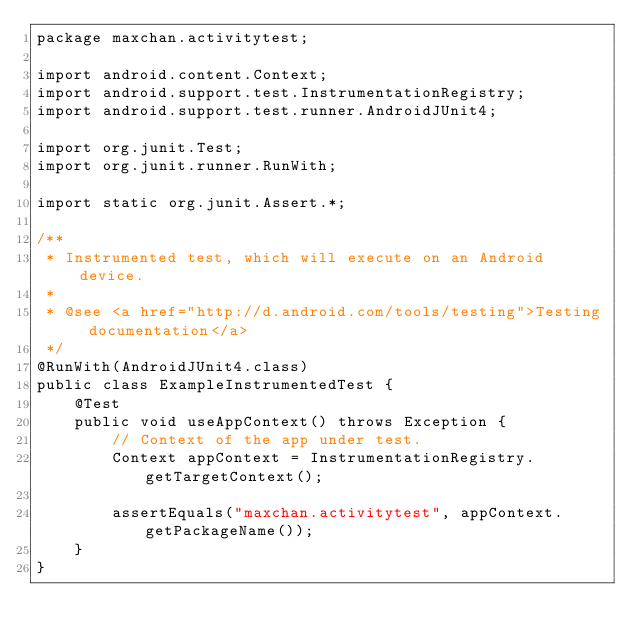<code> <loc_0><loc_0><loc_500><loc_500><_Java_>package maxchan.activitytest;

import android.content.Context;
import android.support.test.InstrumentationRegistry;
import android.support.test.runner.AndroidJUnit4;

import org.junit.Test;
import org.junit.runner.RunWith;

import static org.junit.Assert.*;

/**
 * Instrumented test, which will execute on an Android device.
 *
 * @see <a href="http://d.android.com/tools/testing">Testing documentation</a>
 */
@RunWith(AndroidJUnit4.class)
public class ExampleInstrumentedTest {
    @Test
    public void useAppContext() throws Exception {
        // Context of the app under test.
        Context appContext = InstrumentationRegistry.getTargetContext();

        assertEquals("maxchan.activitytest", appContext.getPackageName());
    }
}
</code> 